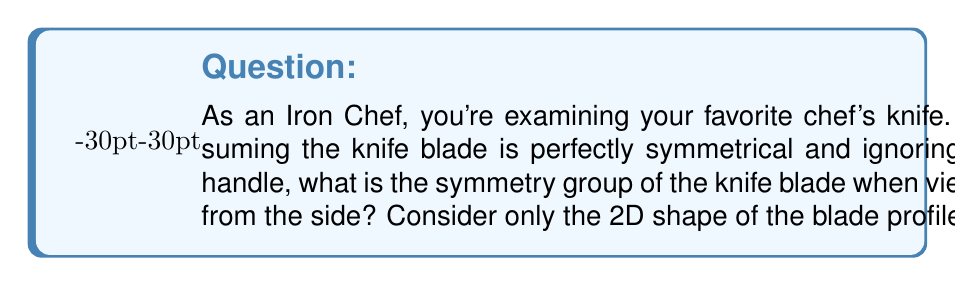Can you solve this math problem? Let's approach this step-by-step:

1) First, we need to visualize the knife blade from the side. It typically has a straight edge on the bottom and a curved edge on top, meeting at a point.

2) To determine the symmetry group, we need to identify all the symmetry operations that leave the shape unchanged:

   a) Rotation: The only rotation that leaves the knife blade unchanged is a 360° rotation, which is equivalent to doing nothing (identity operation).
   
   b) Reflection: There is one line of reflection - a vertical line that bisects the blade from tip to heel.

3) These symmetry operations form a group:
   - The identity operation (do nothing or rotate 360°)
   - The reflection about the vertical bisector

4) This group has only two elements and is isomorphic to the cyclic group of order 2, denoted as $C_2$ or $\mathbb{Z}_2$.

5) In group theory, this is also known as the dihedral group $D_1$, which is the symmetry group of a line segment.

6) The group table for this symmetry group would be:

   $$
   \begin{array}{c|cc}
    * & e & r \\
    \hline
    e & e & r \\
    r & r & e
   \end{array}
   $$

   Where $e$ is the identity operation and $r$ is the reflection.

This group is abelian (commutative) and has order 2.
Answer: The symmetry group of the knife blade viewed from the side is $C_2$ (or $\mathbb{Z}_2$ or $D_1$), the cyclic group of order 2. 